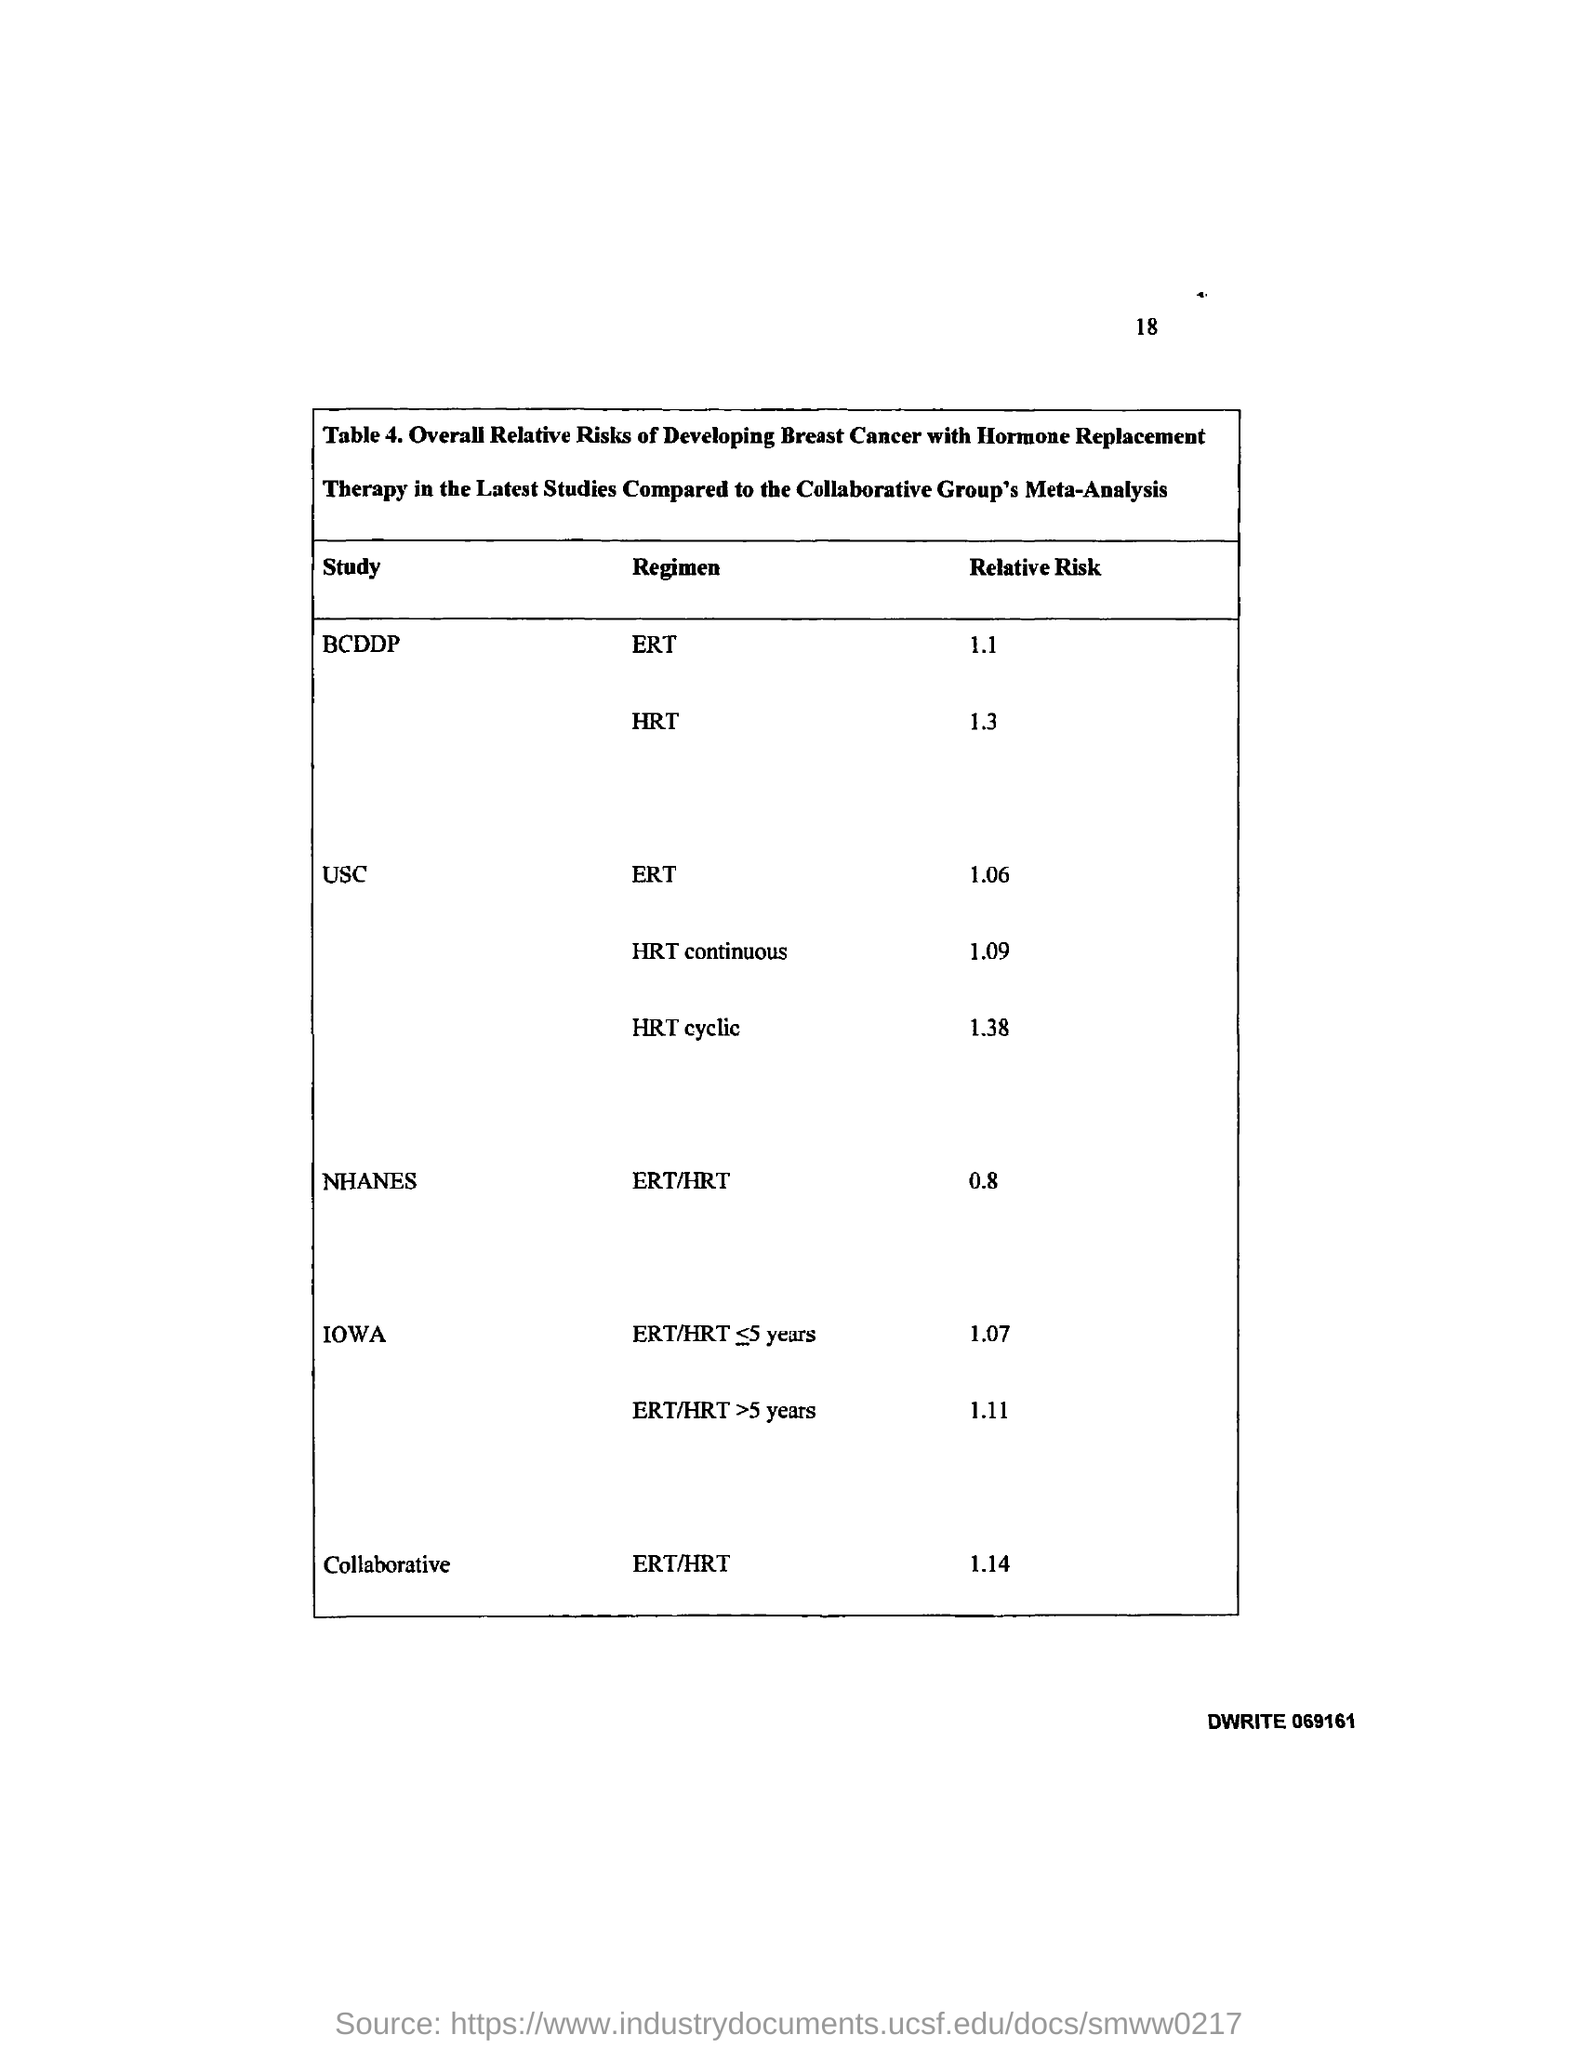Give some essential details in this illustration. The page number is 18. 